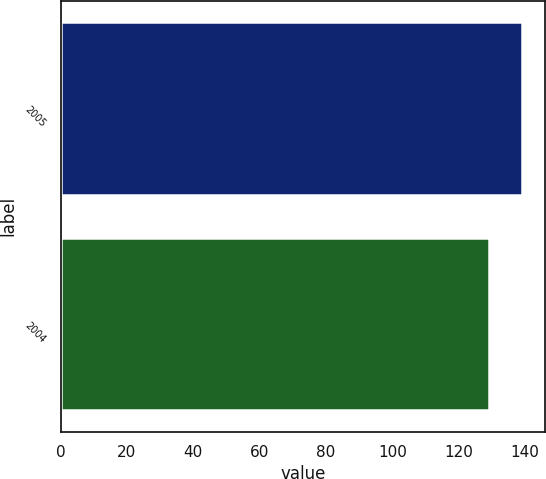<chart> <loc_0><loc_0><loc_500><loc_500><bar_chart><fcel>2005<fcel>2004<nl><fcel>139<fcel>129<nl></chart> 